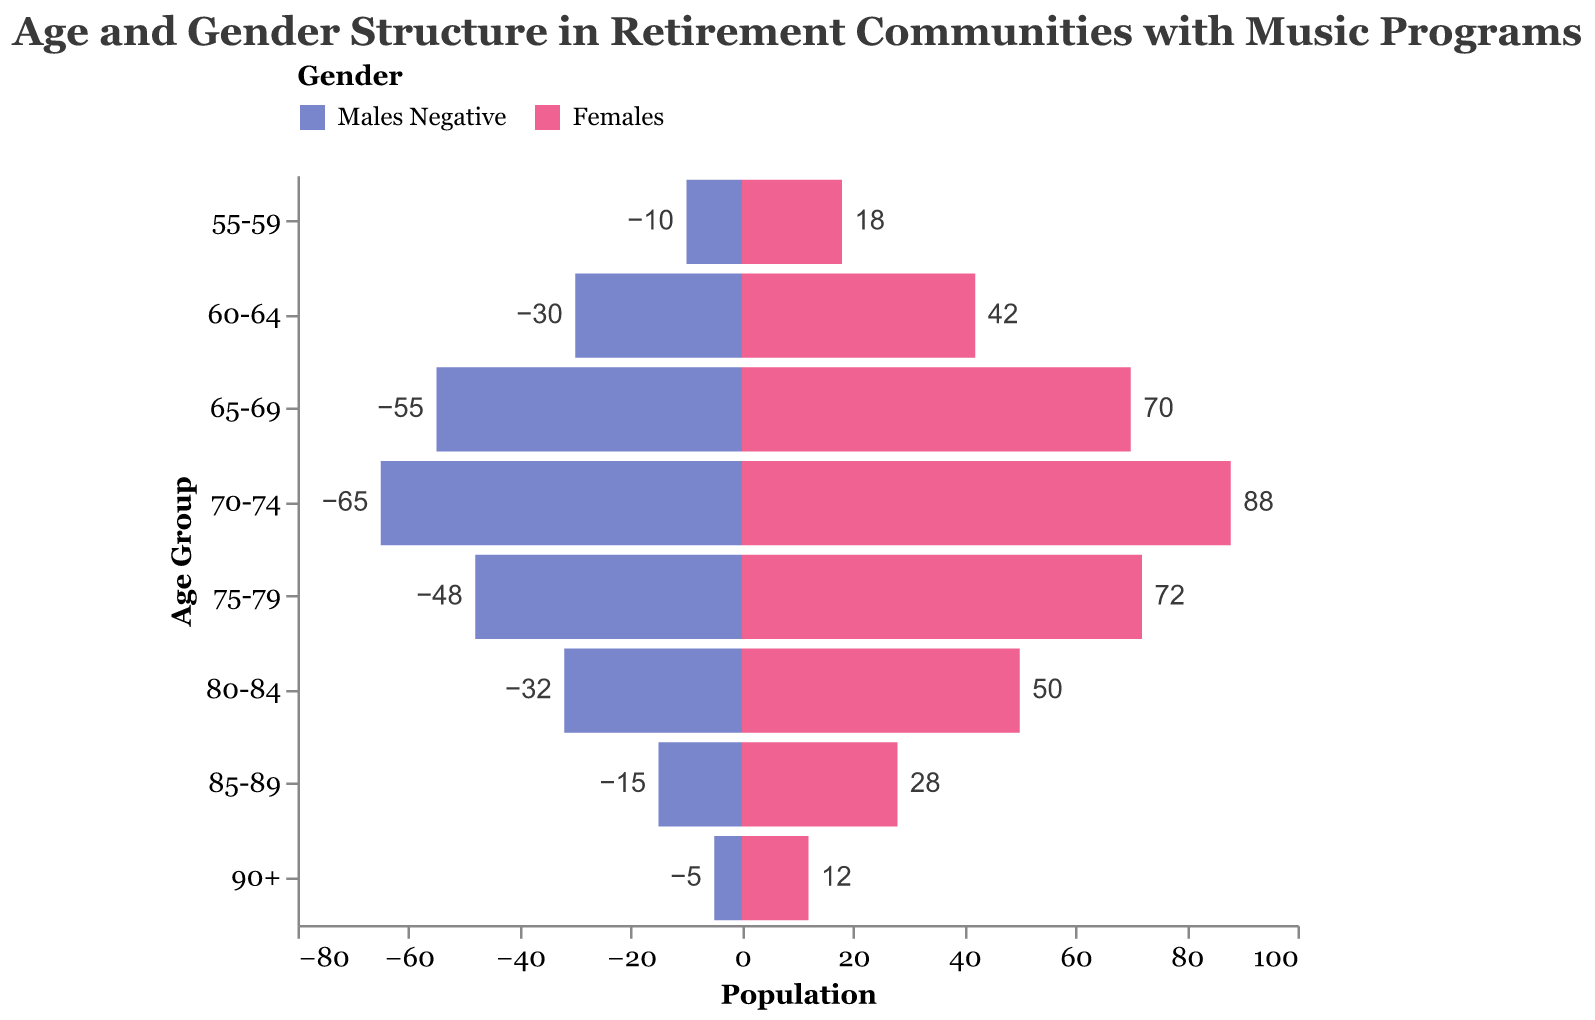What's the title of the figure? The title is provided at the top of the figure and it usually encapsulates the main idea the figure represents. Here, it reads "Age and Gender Structure in Retirement Communities with Music Programs".
Answer: Age and Gender Structure in Retirement Communities with Music Programs Which age group has the highest number of females? Look at the bars for each age group and check which one extends the farthest to the right (positive x-axis direction) under the "Females" color. The "70-74" age group has the longest bar for females, indicating the highest number.
Answer: 70-74 What's the total number of males aged 75 and above? Sum the number of males in the 75-79, 80-84, 85-89, and 90+ age groups. These numbers are 48 (75-79), 32 (80-84), 15 (85-89), and 5 (90+). The total is 48 + 32 + 15 + 5 = 100.
Answer: 100 Which gender has more representation in the "70-74" age group and by how much? Check the bar lengths for both "Males" and "Females" in the "70-74" age group. Females have 88 and males have 65. The difference is 88 - 65 = 23, meaning females have more representation by 23 people.
Answer: Females, by 23 people Compare the number of males in the "65-69" age group to the number of females in "60-64". Which is greater? The bar for "65-69" males extends to -55 and the bar for "60-64" females extends to 42. Comparing absolute values, 55 (males 65-69) is greater than 42 (females 60-64).
Answer: Males in 65-69 How many more females are there than males in the "80-84" age group? The number of males in the "80-84" age group is 32 and the number of females is 50. Subtract the number of males from females: 50 - 32 = 18.
Answer: 18 more females Which age group has the smallest male population? Look at the negative bars representing males and find the shortest one. The "90+" age group has the shortest bar with a count of 5 males, making it the smallest male population.
Answer: 90+ What's the total population (males and females) in the "60-64" age group? Add the number of males and females in the "60-64" age group. Males are 30 and females are 42. The total population is 30 + 42 = 72.
Answer: 72 What's the average number of females across all age groups? Sum the number of females in each age group and divide by the number of age groups. Summing up: 12 + 28 + 50 + 72 + 88 + 70 + 42 + 18 = 380. There are 8 age groups, so the average is 380 / 8 = 47.5.
Answer: 47.5 In which age group do both males and females have the closest population count? Compare the population counts of males and females in each age group and find where the difference is smallest. The "65-69" age group has males = 55 and females = 70, with a difference of 15, which is the closest.
Answer: 65-69 